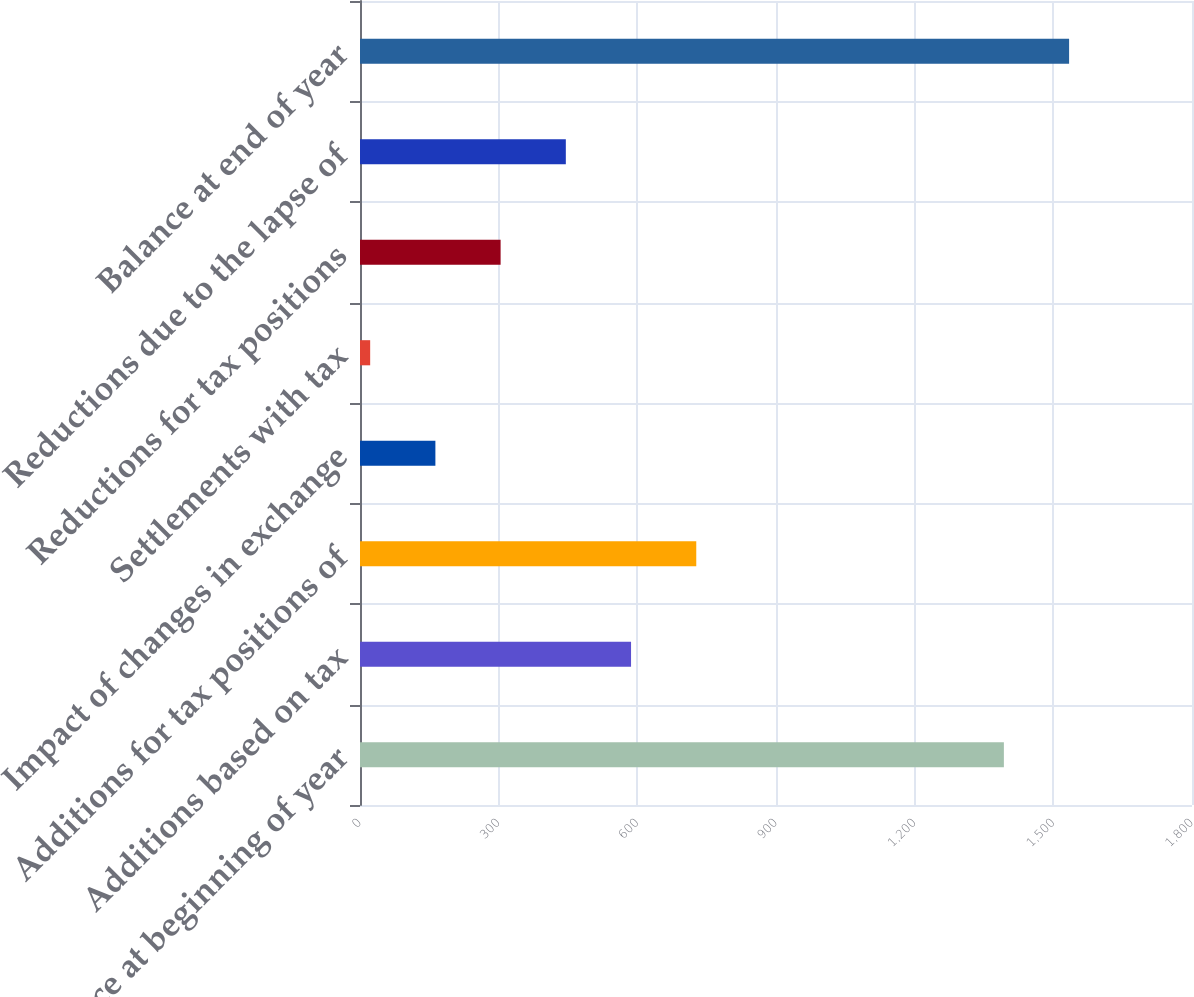<chart> <loc_0><loc_0><loc_500><loc_500><bar_chart><fcel>Balance at beginning of year<fcel>Additions based on tax<fcel>Additions for tax positions of<fcel>Impact of changes in exchange<fcel>Settlements with tax<fcel>Reductions for tax positions<fcel>Reductions due to the lapse of<fcel>Balance at end of year<nl><fcel>1393<fcel>586.4<fcel>727.5<fcel>163.1<fcel>22<fcel>304.2<fcel>445.3<fcel>1534.1<nl></chart> 